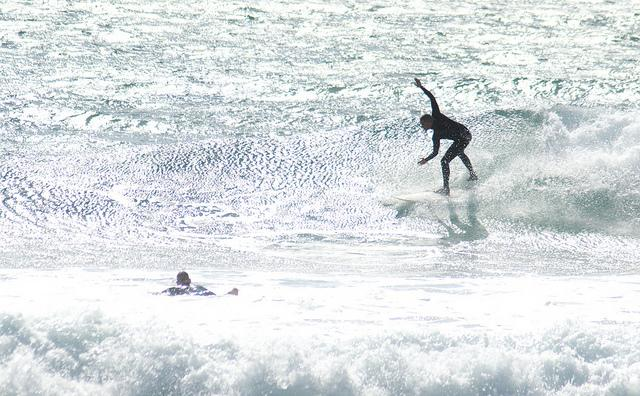Why is the man holding his arms out? balance 